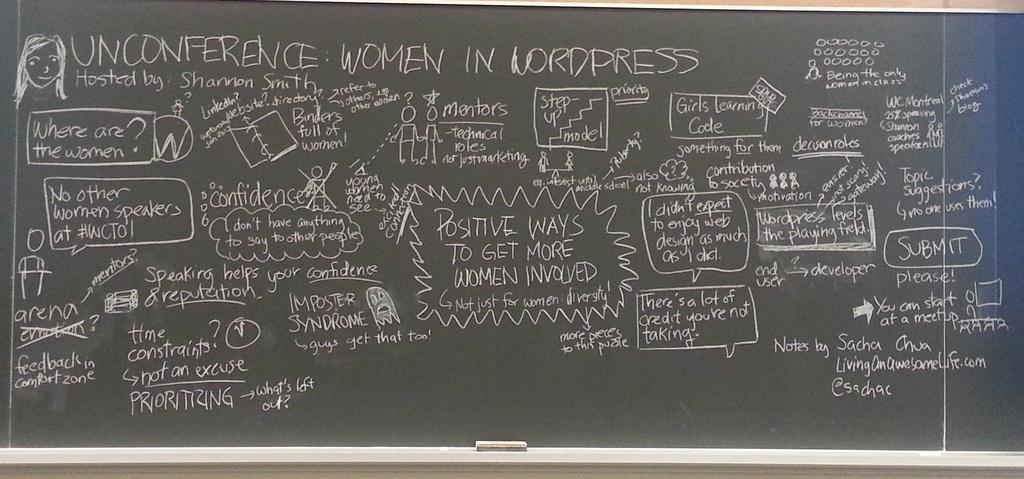Who is hosting?
Offer a terse response. Shannon smith. What types of ways are being used to get women involved?
Your answer should be very brief. Positive. 